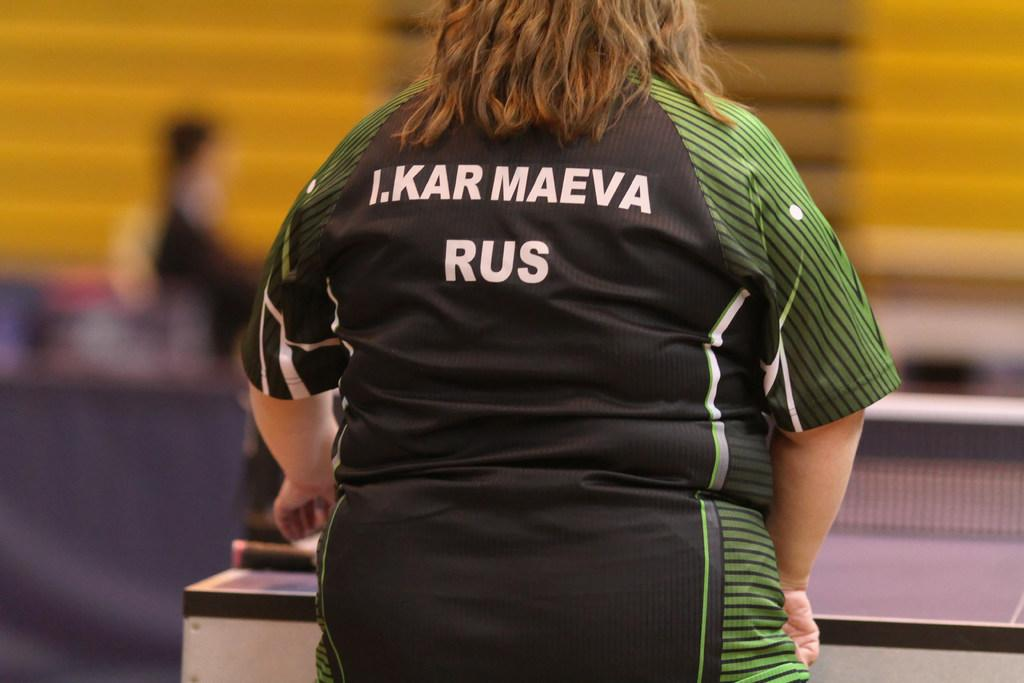What is the main subject of the image? The main subject of the image is a woman. What is the woman doing in the image? The woman is standing in the image. What type of clothing is the woman wearing? The woman is wearing a T-shirt in the image. Can you describe the background of the image? The background of the image is blurred. What type of sack can be seen being carried by the waves in the image? There is no sack or waves present in the image; it features a woman standing with a blurred background. How many boats are visible in the harbor in the image? There is no harbor or boats present in the image. 